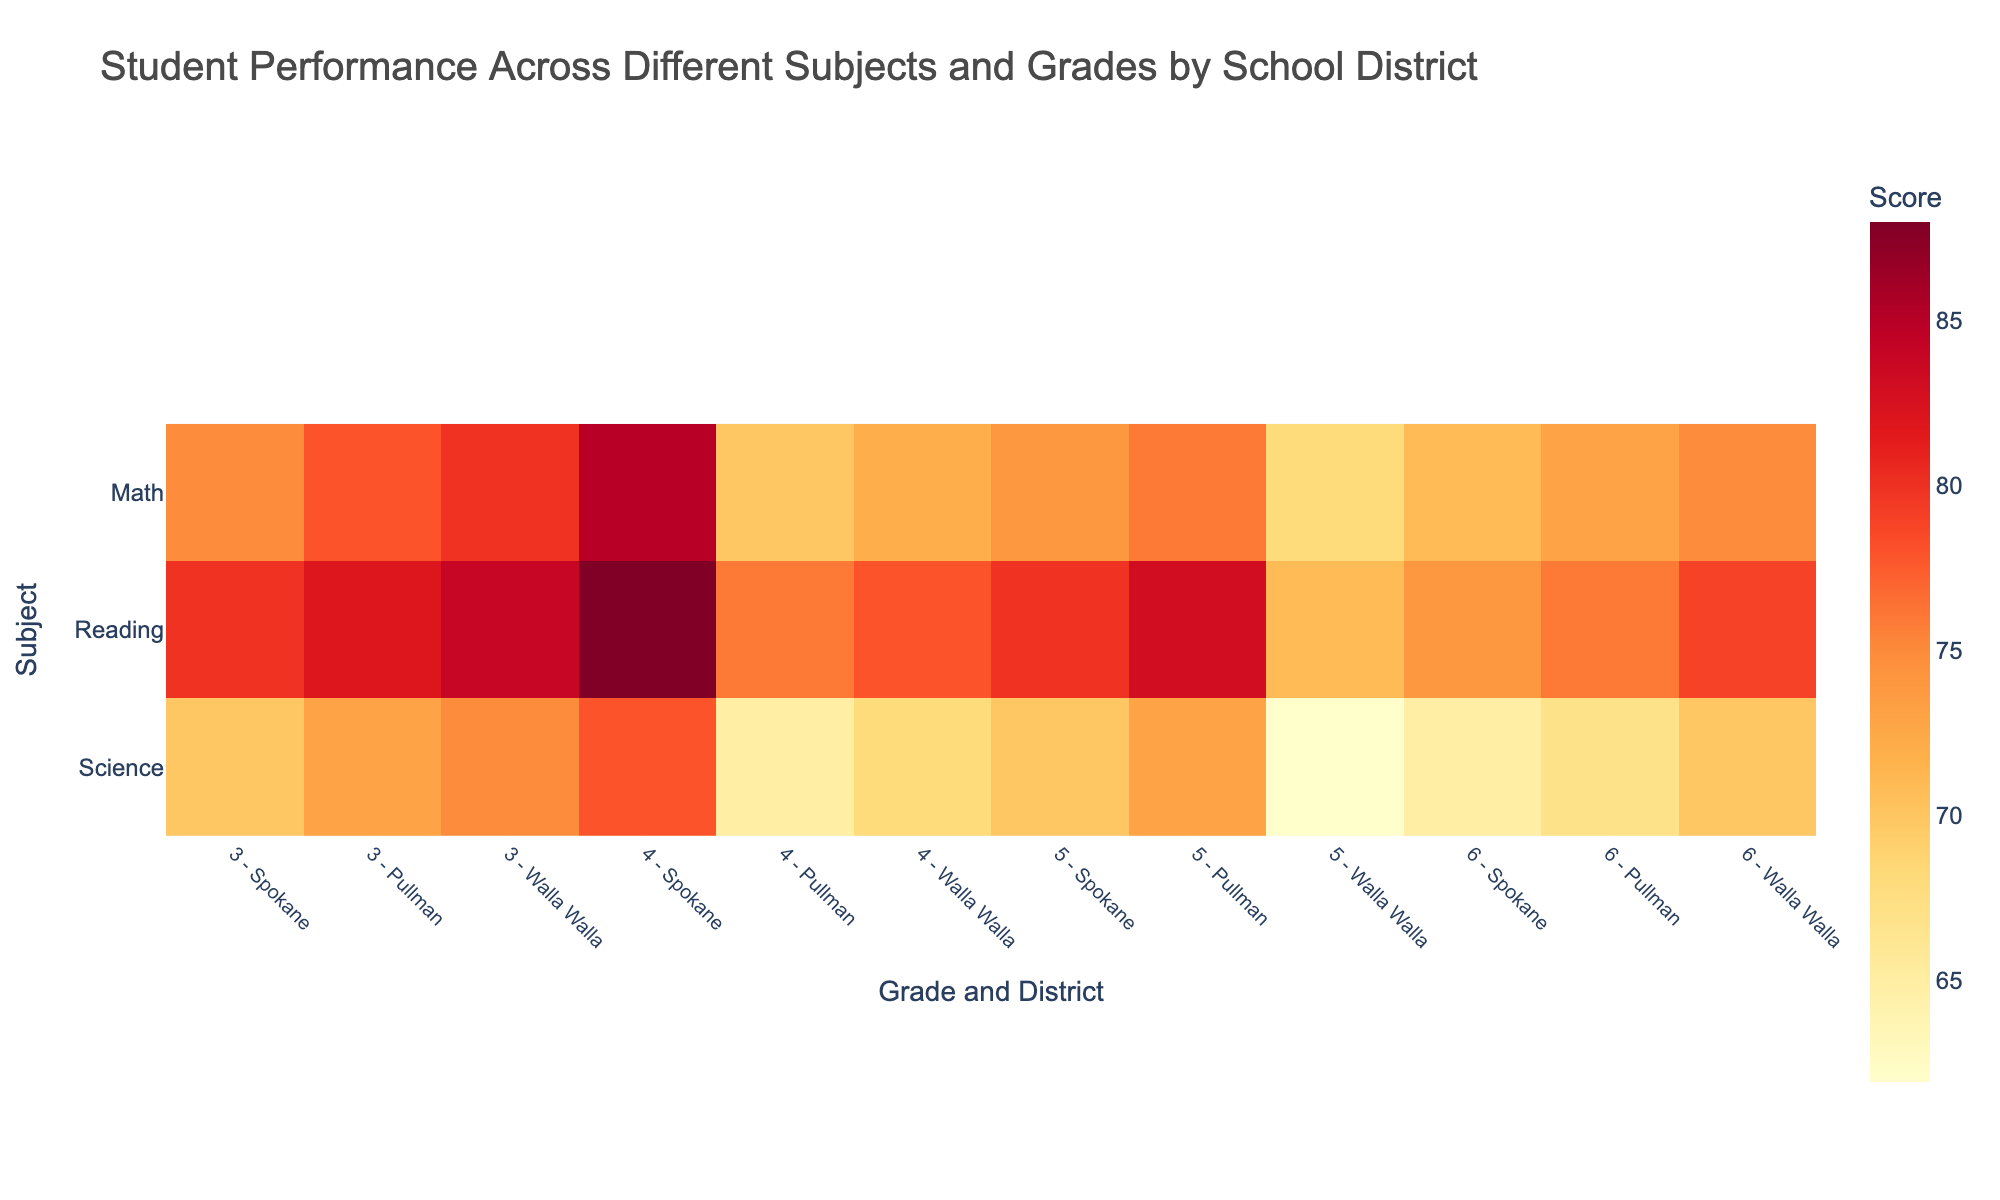what is the highest score for Math among the districts for Grade 6? To determine the highest score for Math among the districts for Grade 6, locate the 'Math' row and the '6' columns for each district (Spokane, Pullman, Walla Walla). The scores are 85 for Spokane, 76 for Pullman, and 75 for Walla Walla. The highest score among these is 85.
Answer: 85 Which subject has the lowest average score across all grades and districts? To find the lowest average score, calculate the average score for each subject across all grades and districts. For Math, the average is (75+78+80+85+70+72+74+76+68+71+73+75)/12=74. For Reading, the average is (80+82+84+88+76+78+80+83+71+74+76+79)/12=79.25. For Science, the average is (70+73+75+78+65+68+70+73+62+65+67+70)/12=69.25. The lowest average score among these subjects is for Science.
Answer: Science What is the difference in the average scores of Science between Spokane and Pullman across all grades? Compute the average Science scores for Spokane and Pullman across all grades. For Spokane, the scores are (70+73+75+78)/4=74. For Pullman, the scores are (65+68+70+73)/4=69. The difference between these averages is 74-69=5.
Answer: 5 How does the Reading score for Walla Walla in Grade 3 compare to the Science score for Walla Walla in the same grade? Locate the Reading score for Walla Walla in Grade 3 (71) and the Science score for Walla Walla in the same grade (62). Reading score is higher.
Answer: Reading is higher What grade and district combination has the lowest score in Science? Examine the Science scores for all grade and district combinations. The minimum score value is 62, which occurs for Walla Walla in Grade 3.
Answer: Grade 3, Walla Walla Which district shows the most improvement in scores from Grade 3 to Grade 6 for Reading? Calculate the difference in scores from Grade 3 to Grade 6 in Reading for each district. For Spokane, the difference is 88-80=8. For Pullman, it's 83-76=7. For Walla Walla, it's 79-71=8. Spokane and Walla Walla both show the most improvement with a difference of 8.
Answer: Spokane and Walla Walla 